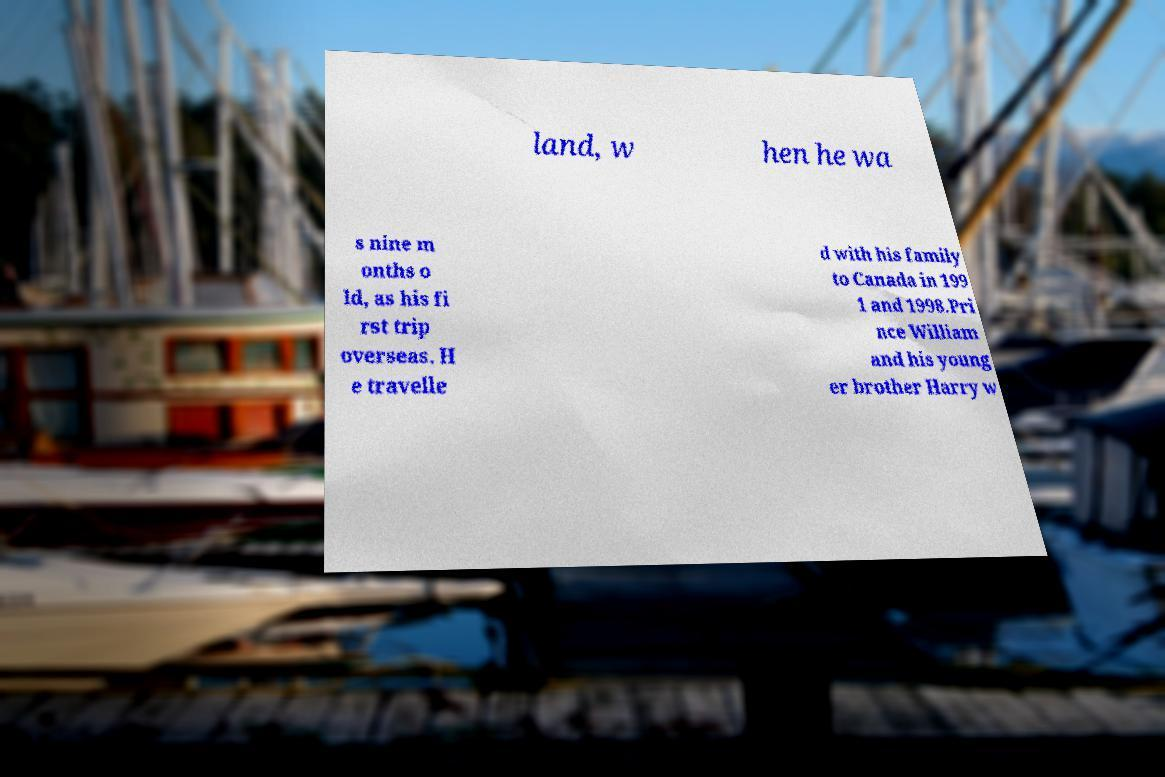Could you assist in decoding the text presented in this image and type it out clearly? land, w hen he wa s nine m onths o ld, as his fi rst trip overseas. H e travelle d with his family to Canada in 199 1 and 1998.Pri nce William and his young er brother Harry w 